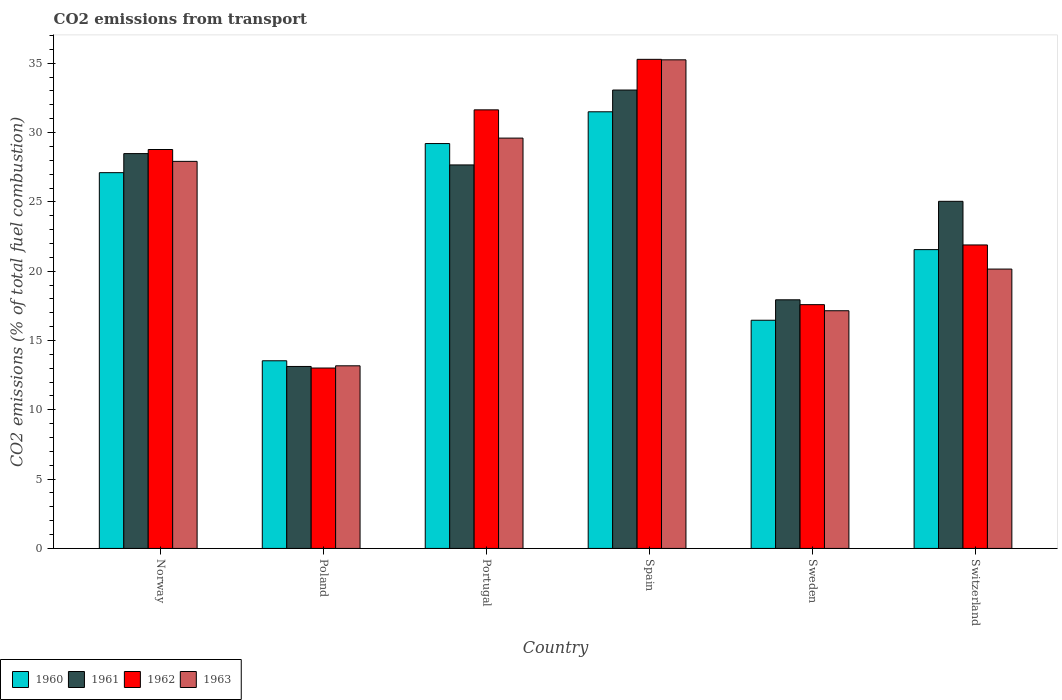How many different coloured bars are there?
Your answer should be compact. 4. How many groups of bars are there?
Give a very brief answer. 6. Are the number of bars per tick equal to the number of legend labels?
Provide a succinct answer. Yes. How many bars are there on the 6th tick from the left?
Offer a terse response. 4. How many bars are there on the 5th tick from the right?
Your answer should be very brief. 4. In how many cases, is the number of bars for a given country not equal to the number of legend labels?
Make the answer very short. 0. What is the total CO2 emitted in 1960 in Switzerland?
Keep it short and to the point. 21.56. Across all countries, what is the maximum total CO2 emitted in 1962?
Provide a short and direct response. 35.28. Across all countries, what is the minimum total CO2 emitted in 1962?
Ensure brevity in your answer.  13.01. In which country was the total CO2 emitted in 1962 maximum?
Keep it short and to the point. Spain. What is the total total CO2 emitted in 1961 in the graph?
Make the answer very short. 145.32. What is the difference between the total CO2 emitted in 1963 in Poland and that in Switzerland?
Provide a short and direct response. -6.98. What is the difference between the total CO2 emitted in 1963 in Switzerland and the total CO2 emitted in 1960 in Poland?
Keep it short and to the point. 6.61. What is the average total CO2 emitted in 1963 per country?
Your answer should be very brief. 23.87. What is the difference between the total CO2 emitted of/in 1961 and total CO2 emitted of/in 1960 in Norway?
Your answer should be compact. 1.38. What is the ratio of the total CO2 emitted in 1962 in Spain to that in Sweden?
Make the answer very short. 2.01. Is the total CO2 emitted in 1960 in Portugal less than that in Switzerland?
Provide a succinct answer. No. What is the difference between the highest and the second highest total CO2 emitted in 1962?
Your answer should be very brief. 6.51. What is the difference between the highest and the lowest total CO2 emitted in 1963?
Your answer should be very brief. 22.07. In how many countries, is the total CO2 emitted in 1962 greater than the average total CO2 emitted in 1962 taken over all countries?
Your answer should be very brief. 3. What does the 1st bar from the left in Switzerland represents?
Your response must be concise. 1960. What does the 1st bar from the right in Spain represents?
Your answer should be very brief. 1963. Is it the case that in every country, the sum of the total CO2 emitted in 1962 and total CO2 emitted in 1961 is greater than the total CO2 emitted in 1960?
Keep it short and to the point. Yes. How many bars are there?
Offer a terse response. 24. Are the values on the major ticks of Y-axis written in scientific E-notation?
Give a very brief answer. No. Does the graph contain any zero values?
Make the answer very short. No. Where does the legend appear in the graph?
Keep it short and to the point. Bottom left. What is the title of the graph?
Offer a very short reply. CO2 emissions from transport. Does "2001" appear as one of the legend labels in the graph?
Offer a terse response. No. What is the label or title of the X-axis?
Your response must be concise. Country. What is the label or title of the Y-axis?
Make the answer very short. CO2 emissions (% of total fuel combustion). What is the CO2 emissions (% of total fuel combustion) of 1960 in Norway?
Ensure brevity in your answer.  27.11. What is the CO2 emissions (% of total fuel combustion) of 1961 in Norway?
Your answer should be very brief. 28.48. What is the CO2 emissions (% of total fuel combustion) of 1962 in Norway?
Keep it short and to the point. 28.78. What is the CO2 emissions (% of total fuel combustion) in 1963 in Norway?
Keep it short and to the point. 27.92. What is the CO2 emissions (% of total fuel combustion) in 1960 in Poland?
Your answer should be very brief. 13.54. What is the CO2 emissions (% of total fuel combustion) of 1961 in Poland?
Keep it short and to the point. 13.13. What is the CO2 emissions (% of total fuel combustion) in 1962 in Poland?
Keep it short and to the point. 13.01. What is the CO2 emissions (% of total fuel combustion) in 1963 in Poland?
Provide a succinct answer. 13.17. What is the CO2 emissions (% of total fuel combustion) of 1960 in Portugal?
Keep it short and to the point. 29.21. What is the CO2 emissions (% of total fuel combustion) in 1961 in Portugal?
Your answer should be compact. 27.67. What is the CO2 emissions (% of total fuel combustion) in 1962 in Portugal?
Offer a terse response. 31.64. What is the CO2 emissions (% of total fuel combustion) of 1963 in Portugal?
Make the answer very short. 29.6. What is the CO2 emissions (% of total fuel combustion) of 1960 in Spain?
Make the answer very short. 31.5. What is the CO2 emissions (% of total fuel combustion) of 1961 in Spain?
Ensure brevity in your answer.  33.07. What is the CO2 emissions (% of total fuel combustion) in 1962 in Spain?
Your answer should be compact. 35.28. What is the CO2 emissions (% of total fuel combustion) of 1963 in Spain?
Your answer should be compact. 35.25. What is the CO2 emissions (% of total fuel combustion) in 1960 in Sweden?
Your answer should be compact. 16.46. What is the CO2 emissions (% of total fuel combustion) of 1961 in Sweden?
Make the answer very short. 17.94. What is the CO2 emissions (% of total fuel combustion) in 1962 in Sweden?
Ensure brevity in your answer.  17.59. What is the CO2 emissions (% of total fuel combustion) in 1963 in Sweden?
Your response must be concise. 17.15. What is the CO2 emissions (% of total fuel combustion) of 1960 in Switzerland?
Your answer should be very brief. 21.56. What is the CO2 emissions (% of total fuel combustion) in 1961 in Switzerland?
Keep it short and to the point. 25.04. What is the CO2 emissions (% of total fuel combustion) in 1962 in Switzerland?
Provide a short and direct response. 21.89. What is the CO2 emissions (% of total fuel combustion) in 1963 in Switzerland?
Keep it short and to the point. 20.15. Across all countries, what is the maximum CO2 emissions (% of total fuel combustion) in 1960?
Offer a terse response. 31.5. Across all countries, what is the maximum CO2 emissions (% of total fuel combustion) of 1961?
Your response must be concise. 33.07. Across all countries, what is the maximum CO2 emissions (% of total fuel combustion) of 1962?
Your answer should be very brief. 35.28. Across all countries, what is the maximum CO2 emissions (% of total fuel combustion) in 1963?
Provide a succinct answer. 35.25. Across all countries, what is the minimum CO2 emissions (% of total fuel combustion) of 1960?
Provide a succinct answer. 13.54. Across all countries, what is the minimum CO2 emissions (% of total fuel combustion) of 1961?
Your response must be concise. 13.13. Across all countries, what is the minimum CO2 emissions (% of total fuel combustion) of 1962?
Make the answer very short. 13.01. Across all countries, what is the minimum CO2 emissions (% of total fuel combustion) of 1963?
Make the answer very short. 13.17. What is the total CO2 emissions (% of total fuel combustion) in 1960 in the graph?
Offer a terse response. 139.37. What is the total CO2 emissions (% of total fuel combustion) of 1961 in the graph?
Make the answer very short. 145.32. What is the total CO2 emissions (% of total fuel combustion) in 1962 in the graph?
Your answer should be very brief. 148.19. What is the total CO2 emissions (% of total fuel combustion) in 1963 in the graph?
Your answer should be very brief. 143.25. What is the difference between the CO2 emissions (% of total fuel combustion) of 1960 in Norway and that in Poland?
Offer a terse response. 13.57. What is the difference between the CO2 emissions (% of total fuel combustion) in 1961 in Norway and that in Poland?
Your answer should be very brief. 15.36. What is the difference between the CO2 emissions (% of total fuel combustion) in 1962 in Norway and that in Poland?
Offer a terse response. 15.76. What is the difference between the CO2 emissions (% of total fuel combustion) in 1963 in Norway and that in Poland?
Provide a short and direct response. 14.75. What is the difference between the CO2 emissions (% of total fuel combustion) of 1960 in Norway and that in Portugal?
Make the answer very short. -2.1. What is the difference between the CO2 emissions (% of total fuel combustion) of 1961 in Norway and that in Portugal?
Keep it short and to the point. 0.82. What is the difference between the CO2 emissions (% of total fuel combustion) in 1962 in Norway and that in Portugal?
Offer a terse response. -2.86. What is the difference between the CO2 emissions (% of total fuel combustion) of 1963 in Norway and that in Portugal?
Provide a short and direct response. -1.68. What is the difference between the CO2 emissions (% of total fuel combustion) in 1960 in Norway and that in Spain?
Your answer should be compact. -4.39. What is the difference between the CO2 emissions (% of total fuel combustion) of 1961 in Norway and that in Spain?
Your answer should be compact. -4.58. What is the difference between the CO2 emissions (% of total fuel combustion) of 1962 in Norway and that in Spain?
Keep it short and to the point. -6.51. What is the difference between the CO2 emissions (% of total fuel combustion) in 1963 in Norway and that in Spain?
Offer a very short reply. -7.33. What is the difference between the CO2 emissions (% of total fuel combustion) of 1960 in Norway and that in Sweden?
Offer a very short reply. 10.65. What is the difference between the CO2 emissions (% of total fuel combustion) in 1961 in Norway and that in Sweden?
Provide a short and direct response. 10.55. What is the difference between the CO2 emissions (% of total fuel combustion) of 1962 in Norway and that in Sweden?
Offer a very short reply. 11.19. What is the difference between the CO2 emissions (% of total fuel combustion) in 1963 in Norway and that in Sweden?
Give a very brief answer. 10.78. What is the difference between the CO2 emissions (% of total fuel combustion) of 1960 in Norway and that in Switzerland?
Offer a very short reply. 5.55. What is the difference between the CO2 emissions (% of total fuel combustion) in 1961 in Norway and that in Switzerland?
Your answer should be compact. 3.44. What is the difference between the CO2 emissions (% of total fuel combustion) in 1962 in Norway and that in Switzerland?
Provide a short and direct response. 6.88. What is the difference between the CO2 emissions (% of total fuel combustion) of 1963 in Norway and that in Switzerland?
Your answer should be very brief. 7.77. What is the difference between the CO2 emissions (% of total fuel combustion) of 1960 in Poland and that in Portugal?
Provide a short and direct response. -15.67. What is the difference between the CO2 emissions (% of total fuel combustion) in 1961 in Poland and that in Portugal?
Your answer should be compact. -14.54. What is the difference between the CO2 emissions (% of total fuel combustion) in 1962 in Poland and that in Portugal?
Keep it short and to the point. -18.62. What is the difference between the CO2 emissions (% of total fuel combustion) in 1963 in Poland and that in Portugal?
Give a very brief answer. -16.43. What is the difference between the CO2 emissions (% of total fuel combustion) in 1960 in Poland and that in Spain?
Make the answer very short. -17.96. What is the difference between the CO2 emissions (% of total fuel combustion) in 1961 in Poland and that in Spain?
Give a very brief answer. -19.94. What is the difference between the CO2 emissions (% of total fuel combustion) of 1962 in Poland and that in Spain?
Keep it short and to the point. -22.27. What is the difference between the CO2 emissions (% of total fuel combustion) of 1963 in Poland and that in Spain?
Provide a succinct answer. -22.07. What is the difference between the CO2 emissions (% of total fuel combustion) of 1960 in Poland and that in Sweden?
Make the answer very short. -2.92. What is the difference between the CO2 emissions (% of total fuel combustion) in 1961 in Poland and that in Sweden?
Keep it short and to the point. -4.81. What is the difference between the CO2 emissions (% of total fuel combustion) in 1962 in Poland and that in Sweden?
Provide a short and direct response. -4.57. What is the difference between the CO2 emissions (% of total fuel combustion) of 1963 in Poland and that in Sweden?
Ensure brevity in your answer.  -3.97. What is the difference between the CO2 emissions (% of total fuel combustion) in 1960 in Poland and that in Switzerland?
Give a very brief answer. -8.02. What is the difference between the CO2 emissions (% of total fuel combustion) of 1961 in Poland and that in Switzerland?
Your answer should be compact. -11.91. What is the difference between the CO2 emissions (% of total fuel combustion) in 1962 in Poland and that in Switzerland?
Provide a short and direct response. -8.88. What is the difference between the CO2 emissions (% of total fuel combustion) in 1963 in Poland and that in Switzerland?
Your answer should be compact. -6.98. What is the difference between the CO2 emissions (% of total fuel combustion) of 1960 in Portugal and that in Spain?
Your answer should be very brief. -2.29. What is the difference between the CO2 emissions (% of total fuel combustion) in 1961 in Portugal and that in Spain?
Make the answer very short. -5.4. What is the difference between the CO2 emissions (% of total fuel combustion) in 1962 in Portugal and that in Spain?
Provide a short and direct response. -3.64. What is the difference between the CO2 emissions (% of total fuel combustion) in 1963 in Portugal and that in Spain?
Keep it short and to the point. -5.65. What is the difference between the CO2 emissions (% of total fuel combustion) of 1960 in Portugal and that in Sweden?
Provide a short and direct response. 12.75. What is the difference between the CO2 emissions (% of total fuel combustion) in 1961 in Portugal and that in Sweden?
Provide a short and direct response. 9.73. What is the difference between the CO2 emissions (% of total fuel combustion) in 1962 in Portugal and that in Sweden?
Provide a succinct answer. 14.05. What is the difference between the CO2 emissions (% of total fuel combustion) of 1963 in Portugal and that in Sweden?
Offer a terse response. 12.45. What is the difference between the CO2 emissions (% of total fuel combustion) in 1960 in Portugal and that in Switzerland?
Keep it short and to the point. 7.65. What is the difference between the CO2 emissions (% of total fuel combustion) in 1961 in Portugal and that in Switzerland?
Your response must be concise. 2.62. What is the difference between the CO2 emissions (% of total fuel combustion) in 1962 in Portugal and that in Switzerland?
Your response must be concise. 9.75. What is the difference between the CO2 emissions (% of total fuel combustion) of 1963 in Portugal and that in Switzerland?
Your response must be concise. 9.45. What is the difference between the CO2 emissions (% of total fuel combustion) of 1960 in Spain and that in Sweden?
Your answer should be compact. 15.04. What is the difference between the CO2 emissions (% of total fuel combustion) of 1961 in Spain and that in Sweden?
Your answer should be compact. 15.13. What is the difference between the CO2 emissions (% of total fuel combustion) in 1962 in Spain and that in Sweden?
Ensure brevity in your answer.  17.7. What is the difference between the CO2 emissions (% of total fuel combustion) of 1963 in Spain and that in Sweden?
Provide a short and direct response. 18.1. What is the difference between the CO2 emissions (% of total fuel combustion) of 1960 in Spain and that in Switzerland?
Provide a short and direct response. 9.94. What is the difference between the CO2 emissions (% of total fuel combustion) of 1961 in Spain and that in Switzerland?
Offer a terse response. 8.03. What is the difference between the CO2 emissions (% of total fuel combustion) in 1962 in Spain and that in Switzerland?
Your answer should be compact. 13.39. What is the difference between the CO2 emissions (% of total fuel combustion) of 1963 in Spain and that in Switzerland?
Your answer should be compact. 15.1. What is the difference between the CO2 emissions (% of total fuel combustion) in 1960 in Sweden and that in Switzerland?
Offer a very short reply. -5.09. What is the difference between the CO2 emissions (% of total fuel combustion) of 1961 in Sweden and that in Switzerland?
Provide a short and direct response. -7.1. What is the difference between the CO2 emissions (% of total fuel combustion) of 1962 in Sweden and that in Switzerland?
Provide a short and direct response. -4.31. What is the difference between the CO2 emissions (% of total fuel combustion) of 1963 in Sweden and that in Switzerland?
Offer a very short reply. -3.01. What is the difference between the CO2 emissions (% of total fuel combustion) of 1960 in Norway and the CO2 emissions (% of total fuel combustion) of 1961 in Poland?
Offer a terse response. 13.98. What is the difference between the CO2 emissions (% of total fuel combustion) of 1960 in Norway and the CO2 emissions (% of total fuel combustion) of 1962 in Poland?
Offer a terse response. 14.09. What is the difference between the CO2 emissions (% of total fuel combustion) in 1960 in Norway and the CO2 emissions (% of total fuel combustion) in 1963 in Poland?
Ensure brevity in your answer.  13.93. What is the difference between the CO2 emissions (% of total fuel combustion) in 1961 in Norway and the CO2 emissions (% of total fuel combustion) in 1962 in Poland?
Provide a short and direct response. 15.47. What is the difference between the CO2 emissions (% of total fuel combustion) of 1961 in Norway and the CO2 emissions (% of total fuel combustion) of 1963 in Poland?
Provide a succinct answer. 15.31. What is the difference between the CO2 emissions (% of total fuel combustion) in 1962 in Norway and the CO2 emissions (% of total fuel combustion) in 1963 in Poland?
Your answer should be very brief. 15.6. What is the difference between the CO2 emissions (% of total fuel combustion) in 1960 in Norway and the CO2 emissions (% of total fuel combustion) in 1961 in Portugal?
Ensure brevity in your answer.  -0.56. What is the difference between the CO2 emissions (% of total fuel combustion) in 1960 in Norway and the CO2 emissions (% of total fuel combustion) in 1962 in Portugal?
Your response must be concise. -4.53. What is the difference between the CO2 emissions (% of total fuel combustion) of 1960 in Norway and the CO2 emissions (% of total fuel combustion) of 1963 in Portugal?
Provide a succinct answer. -2.49. What is the difference between the CO2 emissions (% of total fuel combustion) of 1961 in Norway and the CO2 emissions (% of total fuel combustion) of 1962 in Portugal?
Your response must be concise. -3.16. What is the difference between the CO2 emissions (% of total fuel combustion) of 1961 in Norway and the CO2 emissions (% of total fuel combustion) of 1963 in Portugal?
Provide a succinct answer. -1.12. What is the difference between the CO2 emissions (% of total fuel combustion) in 1962 in Norway and the CO2 emissions (% of total fuel combustion) in 1963 in Portugal?
Keep it short and to the point. -0.82. What is the difference between the CO2 emissions (% of total fuel combustion) of 1960 in Norway and the CO2 emissions (% of total fuel combustion) of 1961 in Spain?
Your answer should be very brief. -5.96. What is the difference between the CO2 emissions (% of total fuel combustion) of 1960 in Norway and the CO2 emissions (% of total fuel combustion) of 1962 in Spain?
Your response must be concise. -8.18. What is the difference between the CO2 emissions (% of total fuel combustion) in 1960 in Norway and the CO2 emissions (% of total fuel combustion) in 1963 in Spain?
Keep it short and to the point. -8.14. What is the difference between the CO2 emissions (% of total fuel combustion) in 1961 in Norway and the CO2 emissions (% of total fuel combustion) in 1962 in Spain?
Offer a terse response. -6.8. What is the difference between the CO2 emissions (% of total fuel combustion) in 1961 in Norway and the CO2 emissions (% of total fuel combustion) in 1963 in Spain?
Provide a succinct answer. -6.77. What is the difference between the CO2 emissions (% of total fuel combustion) in 1962 in Norway and the CO2 emissions (% of total fuel combustion) in 1963 in Spain?
Provide a succinct answer. -6.47. What is the difference between the CO2 emissions (% of total fuel combustion) of 1960 in Norway and the CO2 emissions (% of total fuel combustion) of 1961 in Sweden?
Your answer should be very brief. 9.17. What is the difference between the CO2 emissions (% of total fuel combustion) of 1960 in Norway and the CO2 emissions (% of total fuel combustion) of 1962 in Sweden?
Your answer should be very brief. 9.52. What is the difference between the CO2 emissions (% of total fuel combustion) of 1960 in Norway and the CO2 emissions (% of total fuel combustion) of 1963 in Sweden?
Your answer should be compact. 9.96. What is the difference between the CO2 emissions (% of total fuel combustion) in 1961 in Norway and the CO2 emissions (% of total fuel combustion) in 1962 in Sweden?
Make the answer very short. 10.9. What is the difference between the CO2 emissions (% of total fuel combustion) in 1961 in Norway and the CO2 emissions (% of total fuel combustion) in 1963 in Sweden?
Your answer should be very brief. 11.34. What is the difference between the CO2 emissions (% of total fuel combustion) in 1962 in Norway and the CO2 emissions (% of total fuel combustion) in 1963 in Sweden?
Your answer should be very brief. 11.63. What is the difference between the CO2 emissions (% of total fuel combustion) of 1960 in Norway and the CO2 emissions (% of total fuel combustion) of 1961 in Switzerland?
Offer a terse response. 2.07. What is the difference between the CO2 emissions (% of total fuel combustion) in 1960 in Norway and the CO2 emissions (% of total fuel combustion) in 1962 in Switzerland?
Offer a very short reply. 5.21. What is the difference between the CO2 emissions (% of total fuel combustion) in 1960 in Norway and the CO2 emissions (% of total fuel combustion) in 1963 in Switzerland?
Your response must be concise. 6.95. What is the difference between the CO2 emissions (% of total fuel combustion) of 1961 in Norway and the CO2 emissions (% of total fuel combustion) of 1962 in Switzerland?
Offer a very short reply. 6.59. What is the difference between the CO2 emissions (% of total fuel combustion) in 1961 in Norway and the CO2 emissions (% of total fuel combustion) in 1963 in Switzerland?
Provide a short and direct response. 8.33. What is the difference between the CO2 emissions (% of total fuel combustion) in 1962 in Norway and the CO2 emissions (% of total fuel combustion) in 1963 in Switzerland?
Offer a very short reply. 8.63. What is the difference between the CO2 emissions (% of total fuel combustion) in 1960 in Poland and the CO2 emissions (% of total fuel combustion) in 1961 in Portugal?
Offer a very short reply. -14.13. What is the difference between the CO2 emissions (% of total fuel combustion) of 1960 in Poland and the CO2 emissions (% of total fuel combustion) of 1962 in Portugal?
Ensure brevity in your answer.  -18.1. What is the difference between the CO2 emissions (% of total fuel combustion) in 1960 in Poland and the CO2 emissions (% of total fuel combustion) in 1963 in Portugal?
Provide a short and direct response. -16.06. What is the difference between the CO2 emissions (% of total fuel combustion) of 1961 in Poland and the CO2 emissions (% of total fuel combustion) of 1962 in Portugal?
Make the answer very short. -18.51. What is the difference between the CO2 emissions (% of total fuel combustion) of 1961 in Poland and the CO2 emissions (% of total fuel combustion) of 1963 in Portugal?
Ensure brevity in your answer.  -16.47. What is the difference between the CO2 emissions (% of total fuel combustion) in 1962 in Poland and the CO2 emissions (% of total fuel combustion) in 1963 in Portugal?
Offer a terse response. -16.59. What is the difference between the CO2 emissions (% of total fuel combustion) in 1960 in Poland and the CO2 emissions (% of total fuel combustion) in 1961 in Spain?
Your answer should be very brief. -19.53. What is the difference between the CO2 emissions (% of total fuel combustion) in 1960 in Poland and the CO2 emissions (% of total fuel combustion) in 1962 in Spain?
Your answer should be compact. -21.75. What is the difference between the CO2 emissions (% of total fuel combustion) of 1960 in Poland and the CO2 emissions (% of total fuel combustion) of 1963 in Spain?
Offer a very short reply. -21.71. What is the difference between the CO2 emissions (% of total fuel combustion) of 1961 in Poland and the CO2 emissions (% of total fuel combustion) of 1962 in Spain?
Give a very brief answer. -22.16. What is the difference between the CO2 emissions (% of total fuel combustion) of 1961 in Poland and the CO2 emissions (% of total fuel combustion) of 1963 in Spain?
Keep it short and to the point. -22.12. What is the difference between the CO2 emissions (% of total fuel combustion) in 1962 in Poland and the CO2 emissions (% of total fuel combustion) in 1963 in Spain?
Keep it short and to the point. -22.23. What is the difference between the CO2 emissions (% of total fuel combustion) in 1960 in Poland and the CO2 emissions (% of total fuel combustion) in 1961 in Sweden?
Provide a succinct answer. -4.4. What is the difference between the CO2 emissions (% of total fuel combustion) of 1960 in Poland and the CO2 emissions (% of total fuel combustion) of 1962 in Sweden?
Offer a very short reply. -4.05. What is the difference between the CO2 emissions (% of total fuel combustion) of 1960 in Poland and the CO2 emissions (% of total fuel combustion) of 1963 in Sweden?
Your answer should be compact. -3.61. What is the difference between the CO2 emissions (% of total fuel combustion) in 1961 in Poland and the CO2 emissions (% of total fuel combustion) in 1962 in Sweden?
Provide a succinct answer. -4.46. What is the difference between the CO2 emissions (% of total fuel combustion) of 1961 in Poland and the CO2 emissions (% of total fuel combustion) of 1963 in Sweden?
Your answer should be very brief. -4.02. What is the difference between the CO2 emissions (% of total fuel combustion) of 1962 in Poland and the CO2 emissions (% of total fuel combustion) of 1963 in Sweden?
Offer a very short reply. -4.13. What is the difference between the CO2 emissions (% of total fuel combustion) in 1960 in Poland and the CO2 emissions (% of total fuel combustion) in 1961 in Switzerland?
Your answer should be compact. -11.5. What is the difference between the CO2 emissions (% of total fuel combustion) of 1960 in Poland and the CO2 emissions (% of total fuel combustion) of 1962 in Switzerland?
Provide a short and direct response. -8.36. What is the difference between the CO2 emissions (% of total fuel combustion) of 1960 in Poland and the CO2 emissions (% of total fuel combustion) of 1963 in Switzerland?
Your answer should be compact. -6.61. What is the difference between the CO2 emissions (% of total fuel combustion) in 1961 in Poland and the CO2 emissions (% of total fuel combustion) in 1962 in Switzerland?
Provide a succinct answer. -8.77. What is the difference between the CO2 emissions (% of total fuel combustion) in 1961 in Poland and the CO2 emissions (% of total fuel combustion) in 1963 in Switzerland?
Your response must be concise. -7.02. What is the difference between the CO2 emissions (% of total fuel combustion) of 1962 in Poland and the CO2 emissions (% of total fuel combustion) of 1963 in Switzerland?
Provide a short and direct response. -7.14. What is the difference between the CO2 emissions (% of total fuel combustion) in 1960 in Portugal and the CO2 emissions (% of total fuel combustion) in 1961 in Spain?
Your response must be concise. -3.86. What is the difference between the CO2 emissions (% of total fuel combustion) in 1960 in Portugal and the CO2 emissions (% of total fuel combustion) in 1962 in Spain?
Offer a terse response. -6.08. What is the difference between the CO2 emissions (% of total fuel combustion) in 1960 in Portugal and the CO2 emissions (% of total fuel combustion) in 1963 in Spain?
Give a very brief answer. -6.04. What is the difference between the CO2 emissions (% of total fuel combustion) in 1961 in Portugal and the CO2 emissions (% of total fuel combustion) in 1962 in Spain?
Your response must be concise. -7.62. What is the difference between the CO2 emissions (% of total fuel combustion) of 1961 in Portugal and the CO2 emissions (% of total fuel combustion) of 1963 in Spain?
Your answer should be very brief. -7.58. What is the difference between the CO2 emissions (% of total fuel combustion) of 1962 in Portugal and the CO2 emissions (% of total fuel combustion) of 1963 in Spain?
Ensure brevity in your answer.  -3.61. What is the difference between the CO2 emissions (% of total fuel combustion) of 1960 in Portugal and the CO2 emissions (% of total fuel combustion) of 1961 in Sweden?
Offer a terse response. 11.27. What is the difference between the CO2 emissions (% of total fuel combustion) in 1960 in Portugal and the CO2 emissions (% of total fuel combustion) in 1962 in Sweden?
Offer a terse response. 11.62. What is the difference between the CO2 emissions (% of total fuel combustion) of 1960 in Portugal and the CO2 emissions (% of total fuel combustion) of 1963 in Sweden?
Your response must be concise. 12.06. What is the difference between the CO2 emissions (% of total fuel combustion) in 1961 in Portugal and the CO2 emissions (% of total fuel combustion) in 1962 in Sweden?
Your answer should be very brief. 10.08. What is the difference between the CO2 emissions (% of total fuel combustion) of 1961 in Portugal and the CO2 emissions (% of total fuel combustion) of 1963 in Sweden?
Your response must be concise. 10.52. What is the difference between the CO2 emissions (% of total fuel combustion) of 1962 in Portugal and the CO2 emissions (% of total fuel combustion) of 1963 in Sweden?
Offer a terse response. 14.49. What is the difference between the CO2 emissions (% of total fuel combustion) in 1960 in Portugal and the CO2 emissions (% of total fuel combustion) in 1961 in Switzerland?
Ensure brevity in your answer.  4.17. What is the difference between the CO2 emissions (% of total fuel combustion) of 1960 in Portugal and the CO2 emissions (% of total fuel combustion) of 1962 in Switzerland?
Your answer should be very brief. 7.32. What is the difference between the CO2 emissions (% of total fuel combustion) of 1960 in Portugal and the CO2 emissions (% of total fuel combustion) of 1963 in Switzerland?
Offer a terse response. 9.06. What is the difference between the CO2 emissions (% of total fuel combustion) of 1961 in Portugal and the CO2 emissions (% of total fuel combustion) of 1962 in Switzerland?
Offer a very short reply. 5.77. What is the difference between the CO2 emissions (% of total fuel combustion) of 1961 in Portugal and the CO2 emissions (% of total fuel combustion) of 1963 in Switzerland?
Give a very brief answer. 7.51. What is the difference between the CO2 emissions (% of total fuel combustion) of 1962 in Portugal and the CO2 emissions (% of total fuel combustion) of 1963 in Switzerland?
Your response must be concise. 11.49. What is the difference between the CO2 emissions (% of total fuel combustion) in 1960 in Spain and the CO2 emissions (% of total fuel combustion) in 1961 in Sweden?
Keep it short and to the point. 13.56. What is the difference between the CO2 emissions (% of total fuel combustion) in 1960 in Spain and the CO2 emissions (% of total fuel combustion) in 1962 in Sweden?
Offer a terse response. 13.91. What is the difference between the CO2 emissions (% of total fuel combustion) in 1960 in Spain and the CO2 emissions (% of total fuel combustion) in 1963 in Sweden?
Provide a succinct answer. 14.35. What is the difference between the CO2 emissions (% of total fuel combustion) in 1961 in Spain and the CO2 emissions (% of total fuel combustion) in 1962 in Sweden?
Offer a very short reply. 15.48. What is the difference between the CO2 emissions (% of total fuel combustion) in 1961 in Spain and the CO2 emissions (% of total fuel combustion) in 1963 in Sweden?
Your answer should be compact. 15.92. What is the difference between the CO2 emissions (% of total fuel combustion) of 1962 in Spain and the CO2 emissions (% of total fuel combustion) of 1963 in Sweden?
Offer a terse response. 18.14. What is the difference between the CO2 emissions (% of total fuel combustion) in 1960 in Spain and the CO2 emissions (% of total fuel combustion) in 1961 in Switzerland?
Keep it short and to the point. 6.46. What is the difference between the CO2 emissions (% of total fuel combustion) of 1960 in Spain and the CO2 emissions (% of total fuel combustion) of 1962 in Switzerland?
Your answer should be very brief. 9.61. What is the difference between the CO2 emissions (% of total fuel combustion) in 1960 in Spain and the CO2 emissions (% of total fuel combustion) in 1963 in Switzerland?
Keep it short and to the point. 11.35. What is the difference between the CO2 emissions (% of total fuel combustion) of 1961 in Spain and the CO2 emissions (% of total fuel combustion) of 1962 in Switzerland?
Provide a short and direct response. 11.17. What is the difference between the CO2 emissions (% of total fuel combustion) in 1961 in Spain and the CO2 emissions (% of total fuel combustion) in 1963 in Switzerland?
Offer a very short reply. 12.92. What is the difference between the CO2 emissions (% of total fuel combustion) of 1962 in Spain and the CO2 emissions (% of total fuel combustion) of 1963 in Switzerland?
Ensure brevity in your answer.  15.13. What is the difference between the CO2 emissions (% of total fuel combustion) of 1960 in Sweden and the CO2 emissions (% of total fuel combustion) of 1961 in Switzerland?
Keep it short and to the point. -8.58. What is the difference between the CO2 emissions (% of total fuel combustion) in 1960 in Sweden and the CO2 emissions (% of total fuel combustion) in 1962 in Switzerland?
Your answer should be very brief. -5.43. What is the difference between the CO2 emissions (% of total fuel combustion) of 1960 in Sweden and the CO2 emissions (% of total fuel combustion) of 1963 in Switzerland?
Make the answer very short. -3.69. What is the difference between the CO2 emissions (% of total fuel combustion) in 1961 in Sweden and the CO2 emissions (% of total fuel combustion) in 1962 in Switzerland?
Your response must be concise. -3.96. What is the difference between the CO2 emissions (% of total fuel combustion) of 1961 in Sweden and the CO2 emissions (% of total fuel combustion) of 1963 in Switzerland?
Provide a short and direct response. -2.22. What is the difference between the CO2 emissions (% of total fuel combustion) in 1962 in Sweden and the CO2 emissions (% of total fuel combustion) in 1963 in Switzerland?
Your answer should be very brief. -2.57. What is the average CO2 emissions (% of total fuel combustion) of 1960 per country?
Make the answer very short. 23.23. What is the average CO2 emissions (% of total fuel combustion) in 1961 per country?
Keep it short and to the point. 24.22. What is the average CO2 emissions (% of total fuel combustion) in 1962 per country?
Make the answer very short. 24.7. What is the average CO2 emissions (% of total fuel combustion) of 1963 per country?
Make the answer very short. 23.87. What is the difference between the CO2 emissions (% of total fuel combustion) of 1960 and CO2 emissions (% of total fuel combustion) of 1961 in Norway?
Your answer should be very brief. -1.38. What is the difference between the CO2 emissions (% of total fuel combustion) of 1960 and CO2 emissions (% of total fuel combustion) of 1962 in Norway?
Make the answer very short. -1.67. What is the difference between the CO2 emissions (% of total fuel combustion) in 1960 and CO2 emissions (% of total fuel combustion) in 1963 in Norway?
Offer a very short reply. -0.82. What is the difference between the CO2 emissions (% of total fuel combustion) in 1961 and CO2 emissions (% of total fuel combustion) in 1962 in Norway?
Ensure brevity in your answer.  -0.29. What is the difference between the CO2 emissions (% of total fuel combustion) in 1961 and CO2 emissions (% of total fuel combustion) in 1963 in Norway?
Your answer should be very brief. 0.56. What is the difference between the CO2 emissions (% of total fuel combustion) in 1962 and CO2 emissions (% of total fuel combustion) in 1963 in Norway?
Make the answer very short. 0.85. What is the difference between the CO2 emissions (% of total fuel combustion) of 1960 and CO2 emissions (% of total fuel combustion) of 1961 in Poland?
Keep it short and to the point. 0.41. What is the difference between the CO2 emissions (% of total fuel combustion) of 1960 and CO2 emissions (% of total fuel combustion) of 1962 in Poland?
Make the answer very short. 0.52. What is the difference between the CO2 emissions (% of total fuel combustion) in 1960 and CO2 emissions (% of total fuel combustion) in 1963 in Poland?
Make the answer very short. 0.36. What is the difference between the CO2 emissions (% of total fuel combustion) of 1961 and CO2 emissions (% of total fuel combustion) of 1962 in Poland?
Your answer should be very brief. 0.11. What is the difference between the CO2 emissions (% of total fuel combustion) of 1961 and CO2 emissions (% of total fuel combustion) of 1963 in Poland?
Your answer should be compact. -0.05. What is the difference between the CO2 emissions (% of total fuel combustion) of 1962 and CO2 emissions (% of total fuel combustion) of 1963 in Poland?
Your answer should be very brief. -0.16. What is the difference between the CO2 emissions (% of total fuel combustion) of 1960 and CO2 emissions (% of total fuel combustion) of 1961 in Portugal?
Provide a succinct answer. 1.54. What is the difference between the CO2 emissions (% of total fuel combustion) of 1960 and CO2 emissions (% of total fuel combustion) of 1962 in Portugal?
Provide a short and direct response. -2.43. What is the difference between the CO2 emissions (% of total fuel combustion) in 1960 and CO2 emissions (% of total fuel combustion) in 1963 in Portugal?
Provide a short and direct response. -0.39. What is the difference between the CO2 emissions (% of total fuel combustion) in 1961 and CO2 emissions (% of total fuel combustion) in 1962 in Portugal?
Your answer should be very brief. -3.97. What is the difference between the CO2 emissions (% of total fuel combustion) in 1961 and CO2 emissions (% of total fuel combustion) in 1963 in Portugal?
Your answer should be compact. -1.94. What is the difference between the CO2 emissions (% of total fuel combustion) in 1962 and CO2 emissions (% of total fuel combustion) in 1963 in Portugal?
Provide a succinct answer. 2.04. What is the difference between the CO2 emissions (% of total fuel combustion) of 1960 and CO2 emissions (% of total fuel combustion) of 1961 in Spain?
Your answer should be very brief. -1.57. What is the difference between the CO2 emissions (% of total fuel combustion) in 1960 and CO2 emissions (% of total fuel combustion) in 1962 in Spain?
Ensure brevity in your answer.  -3.78. What is the difference between the CO2 emissions (% of total fuel combustion) in 1960 and CO2 emissions (% of total fuel combustion) in 1963 in Spain?
Keep it short and to the point. -3.75. What is the difference between the CO2 emissions (% of total fuel combustion) of 1961 and CO2 emissions (% of total fuel combustion) of 1962 in Spain?
Provide a succinct answer. -2.22. What is the difference between the CO2 emissions (% of total fuel combustion) in 1961 and CO2 emissions (% of total fuel combustion) in 1963 in Spain?
Provide a succinct answer. -2.18. What is the difference between the CO2 emissions (% of total fuel combustion) of 1962 and CO2 emissions (% of total fuel combustion) of 1963 in Spain?
Give a very brief answer. 0.04. What is the difference between the CO2 emissions (% of total fuel combustion) in 1960 and CO2 emissions (% of total fuel combustion) in 1961 in Sweden?
Your answer should be very brief. -1.47. What is the difference between the CO2 emissions (% of total fuel combustion) of 1960 and CO2 emissions (% of total fuel combustion) of 1962 in Sweden?
Keep it short and to the point. -1.12. What is the difference between the CO2 emissions (% of total fuel combustion) in 1960 and CO2 emissions (% of total fuel combustion) in 1963 in Sweden?
Make the answer very short. -0.69. What is the difference between the CO2 emissions (% of total fuel combustion) in 1961 and CO2 emissions (% of total fuel combustion) in 1962 in Sweden?
Provide a short and direct response. 0.35. What is the difference between the CO2 emissions (% of total fuel combustion) in 1961 and CO2 emissions (% of total fuel combustion) in 1963 in Sweden?
Keep it short and to the point. 0.79. What is the difference between the CO2 emissions (% of total fuel combustion) of 1962 and CO2 emissions (% of total fuel combustion) of 1963 in Sweden?
Your response must be concise. 0.44. What is the difference between the CO2 emissions (% of total fuel combustion) in 1960 and CO2 emissions (% of total fuel combustion) in 1961 in Switzerland?
Provide a succinct answer. -3.48. What is the difference between the CO2 emissions (% of total fuel combustion) of 1960 and CO2 emissions (% of total fuel combustion) of 1962 in Switzerland?
Keep it short and to the point. -0.34. What is the difference between the CO2 emissions (% of total fuel combustion) in 1960 and CO2 emissions (% of total fuel combustion) in 1963 in Switzerland?
Offer a terse response. 1.4. What is the difference between the CO2 emissions (% of total fuel combustion) of 1961 and CO2 emissions (% of total fuel combustion) of 1962 in Switzerland?
Provide a short and direct response. 3.15. What is the difference between the CO2 emissions (% of total fuel combustion) in 1961 and CO2 emissions (% of total fuel combustion) in 1963 in Switzerland?
Provide a short and direct response. 4.89. What is the difference between the CO2 emissions (% of total fuel combustion) of 1962 and CO2 emissions (% of total fuel combustion) of 1963 in Switzerland?
Ensure brevity in your answer.  1.74. What is the ratio of the CO2 emissions (% of total fuel combustion) of 1960 in Norway to that in Poland?
Offer a very short reply. 2. What is the ratio of the CO2 emissions (% of total fuel combustion) in 1961 in Norway to that in Poland?
Your response must be concise. 2.17. What is the ratio of the CO2 emissions (% of total fuel combustion) of 1962 in Norway to that in Poland?
Provide a short and direct response. 2.21. What is the ratio of the CO2 emissions (% of total fuel combustion) in 1963 in Norway to that in Poland?
Provide a short and direct response. 2.12. What is the ratio of the CO2 emissions (% of total fuel combustion) of 1960 in Norway to that in Portugal?
Give a very brief answer. 0.93. What is the ratio of the CO2 emissions (% of total fuel combustion) of 1961 in Norway to that in Portugal?
Offer a very short reply. 1.03. What is the ratio of the CO2 emissions (% of total fuel combustion) in 1962 in Norway to that in Portugal?
Offer a very short reply. 0.91. What is the ratio of the CO2 emissions (% of total fuel combustion) in 1963 in Norway to that in Portugal?
Provide a succinct answer. 0.94. What is the ratio of the CO2 emissions (% of total fuel combustion) of 1960 in Norway to that in Spain?
Your answer should be very brief. 0.86. What is the ratio of the CO2 emissions (% of total fuel combustion) in 1961 in Norway to that in Spain?
Provide a succinct answer. 0.86. What is the ratio of the CO2 emissions (% of total fuel combustion) in 1962 in Norway to that in Spain?
Offer a very short reply. 0.82. What is the ratio of the CO2 emissions (% of total fuel combustion) of 1963 in Norway to that in Spain?
Keep it short and to the point. 0.79. What is the ratio of the CO2 emissions (% of total fuel combustion) in 1960 in Norway to that in Sweden?
Make the answer very short. 1.65. What is the ratio of the CO2 emissions (% of total fuel combustion) in 1961 in Norway to that in Sweden?
Offer a terse response. 1.59. What is the ratio of the CO2 emissions (% of total fuel combustion) in 1962 in Norway to that in Sweden?
Provide a short and direct response. 1.64. What is the ratio of the CO2 emissions (% of total fuel combustion) in 1963 in Norway to that in Sweden?
Keep it short and to the point. 1.63. What is the ratio of the CO2 emissions (% of total fuel combustion) of 1960 in Norway to that in Switzerland?
Your answer should be compact. 1.26. What is the ratio of the CO2 emissions (% of total fuel combustion) of 1961 in Norway to that in Switzerland?
Provide a short and direct response. 1.14. What is the ratio of the CO2 emissions (% of total fuel combustion) of 1962 in Norway to that in Switzerland?
Keep it short and to the point. 1.31. What is the ratio of the CO2 emissions (% of total fuel combustion) of 1963 in Norway to that in Switzerland?
Your answer should be compact. 1.39. What is the ratio of the CO2 emissions (% of total fuel combustion) of 1960 in Poland to that in Portugal?
Offer a terse response. 0.46. What is the ratio of the CO2 emissions (% of total fuel combustion) in 1961 in Poland to that in Portugal?
Your answer should be very brief. 0.47. What is the ratio of the CO2 emissions (% of total fuel combustion) in 1962 in Poland to that in Portugal?
Ensure brevity in your answer.  0.41. What is the ratio of the CO2 emissions (% of total fuel combustion) of 1963 in Poland to that in Portugal?
Provide a short and direct response. 0.45. What is the ratio of the CO2 emissions (% of total fuel combustion) in 1960 in Poland to that in Spain?
Your response must be concise. 0.43. What is the ratio of the CO2 emissions (% of total fuel combustion) in 1961 in Poland to that in Spain?
Give a very brief answer. 0.4. What is the ratio of the CO2 emissions (% of total fuel combustion) of 1962 in Poland to that in Spain?
Offer a terse response. 0.37. What is the ratio of the CO2 emissions (% of total fuel combustion) in 1963 in Poland to that in Spain?
Provide a short and direct response. 0.37. What is the ratio of the CO2 emissions (% of total fuel combustion) of 1960 in Poland to that in Sweden?
Your response must be concise. 0.82. What is the ratio of the CO2 emissions (% of total fuel combustion) in 1961 in Poland to that in Sweden?
Provide a succinct answer. 0.73. What is the ratio of the CO2 emissions (% of total fuel combustion) in 1962 in Poland to that in Sweden?
Give a very brief answer. 0.74. What is the ratio of the CO2 emissions (% of total fuel combustion) of 1963 in Poland to that in Sweden?
Your answer should be compact. 0.77. What is the ratio of the CO2 emissions (% of total fuel combustion) of 1960 in Poland to that in Switzerland?
Offer a terse response. 0.63. What is the ratio of the CO2 emissions (% of total fuel combustion) in 1961 in Poland to that in Switzerland?
Your answer should be very brief. 0.52. What is the ratio of the CO2 emissions (% of total fuel combustion) of 1962 in Poland to that in Switzerland?
Offer a very short reply. 0.59. What is the ratio of the CO2 emissions (% of total fuel combustion) in 1963 in Poland to that in Switzerland?
Your answer should be compact. 0.65. What is the ratio of the CO2 emissions (% of total fuel combustion) in 1960 in Portugal to that in Spain?
Your response must be concise. 0.93. What is the ratio of the CO2 emissions (% of total fuel combustion) of 1961 in Portugal to that in Spain?
Offer a terse response. 0.84. What is the ratio of the CO2 emissions (% of total fuel combustion) of 1962 in Portugal to that in Spain?
Your answer should be compact. 0.9. What is the ratio of the CO2 emissions (% of total fuel combustion) in 1963 in Portugal to that in Spain?
Ensure brevity in your answer.  0.84. What is the ratio of the CO2 emissions (% of total fuel combustion) of 1960 in Portugal to that in Sweden?
Provide a succinct answer. 1.77. What is the ratio of the CO2 emissions (% of total fuel combustion) in 1961 in Portugal to that in Sweden?
Offer a very short reply. 1.54. What is the ratio of the CO2 emissions (% of total fuel combustion) in 1962 in Portugal to that in Sweden?
Offer a terse response. 1.8. What is the ratio of the CO2 emissions (% of total fuel combustion) of 1963 in Portugal to that in Sweden?
Ensure brevity in your answer.  1.73. What is the ratio of the CO2 emissions (% of total fuel combustion) of 1960 in Portugal to that in Switzerland?
Ensure brevity in your answer.  1.35. What is the ratio of the CO2 emissions (% of total fuel combustion) in 1961 in Portugal to that in Switzerland?
Ensure brevity in your answer.  1.1. What is the ratio of the CO2 emissions (% of total fuel combustion) of 1962 in Portugal to that in Switzerland?
Your answer should be very brief. 1.45. What is the ratio of the CO2 emissions (% of total fuel combustion) of 1963 in Portugal to that in Switzerland?
Offer a very short reply. 1.47. What is the ratio of the CO2 emissions (% of total fuel combustion) in 1960 in Spain to that in Sweden?
Provide a short and direct response. 1.91. What is the ratio of the CO2 emissions (% of total fuel combustion) in 1961 in Spain to that in Sweden?
Offer a terse response. 1.84. What is the ratio of the CO2 emissions (% of total fuel combustion) in 1962 in Spain to that in Sweden?
Offer a terse response. 2.01. What is the ratio of the CO2 emissions (% of total fuel combustion) in 1963 in Spain to that in Sweden?
Provide a succinct answer. 2.06. What is the ratio of the CO2 emissions (% of total fuel combustion) of 1960 in Spain to that in Switzerland?
Offer a terse response. 1.46. What is the ratio of the CO2 emissions (% of total fuel combustion) of 1961 in Spain to that in Switzerland?
Ensure brevity in your answer.  1.32. What is the ratio of the CO2 emissions (% of total fuel combustion) of 1962 in Spain to that in Switzerland?
Offer a terse response. 1.61. What is the ratio of the CO2 emissions (% of total fuel combustion) in 1963 in Spain to that in Switzerland?
Make the answer very short. 1.75. What is the ratio of the CO2 emissions (% of total fuel combustion) of 1960 in Sweden to that in Switzerland?
Offer a terse response. 0.76. What is the ratio of the CO2 emissions (% of total fuel combustion) of 1961 in Sweden to that in Switzerland?
Give a very brief answer. 0.72. What is the ratio of the CO2 emissions (% of total fuel combustion) in 1962 in Sweden to that in Switzerland?
Keep it short and to the point. 0.8. What is the ratio of the CO2 emissions (% of total fuel combustion) in 1963 in Sweden to that in Switzerland?
Make the answer very short. 0.85. What is the difference between the highest and the second highest CO2 emissions (% of total fuel combustion) in 1960?
Provide a short and direct response. 2.29. What is the difference between the highest and the second highest CO2 emissions (% of total fuel combustion) of 1961?
Ensure brevity in your answer.  4.58. What is the difference between the highest and the second highest CO2 emissions (% of total fuel combustion) in 1962?
Your answer should be compact. 3.64. What is the difference between the highest and the second highest CO2 emissions (% of total fuel combustion) in 1963?
Ensure brevity in your answer.  5.65. What is the difference between the highest and the lowest CO2 emissions (% of total fuel combustion) of 1960?
Provide a short and direct response. 17.96. What is the difference between the highest and the lowest CO2 emissions (% of total fuel combustion) of 1961?
Provide a short and direct response. 19.94. What is the difference between the highest and the lowest CO2 emissions (% of total fuel combustion) in 1962?
Keep it short and to the point. 22.27. What is the difference between the highest and the lowest CO2 emissions (% of total fuel combustion) of 1963?
Your answer should be very brief. 22.07. 